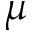Convert formula to latex. <formula><loc_0><loc_0><loc_500><loc_500>\mu</formula> 